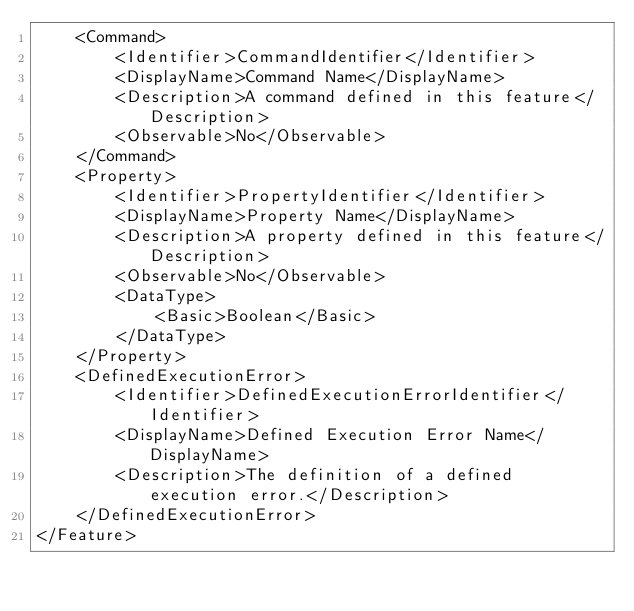<code> <loc_0><loc_0><loc_500><loc_500><_XML_>    <Command>
        <Identifier>CommandIdentifier</Identifier>
        <DisplayName>Command Name</DisplayName>
        <Description>A command defined in this feature</Description>
        <Observable>No</Observable>
    </Command>
    <Property>
        <Identifier>PropertyIdentifier</Identifier>
        <DisplayName>Property Name</DisplayName>
        <Description>A property defined in this feature</Description>
        <Observable>No</Observable>
        <DataType>
            <Basic>Boolean</Basic>
        </DataType>
    </Property>
    <DefinedExecutionError>
        <Identifier>DefinedExecutionErrorIdentifier</Identifier>
        <DisplayName>Defined Execution Error Name</DisplayName>
        <Description>The definition of a defined execution error.</Description>
    </DefinedExecutionError>
</Feature>
</code> 